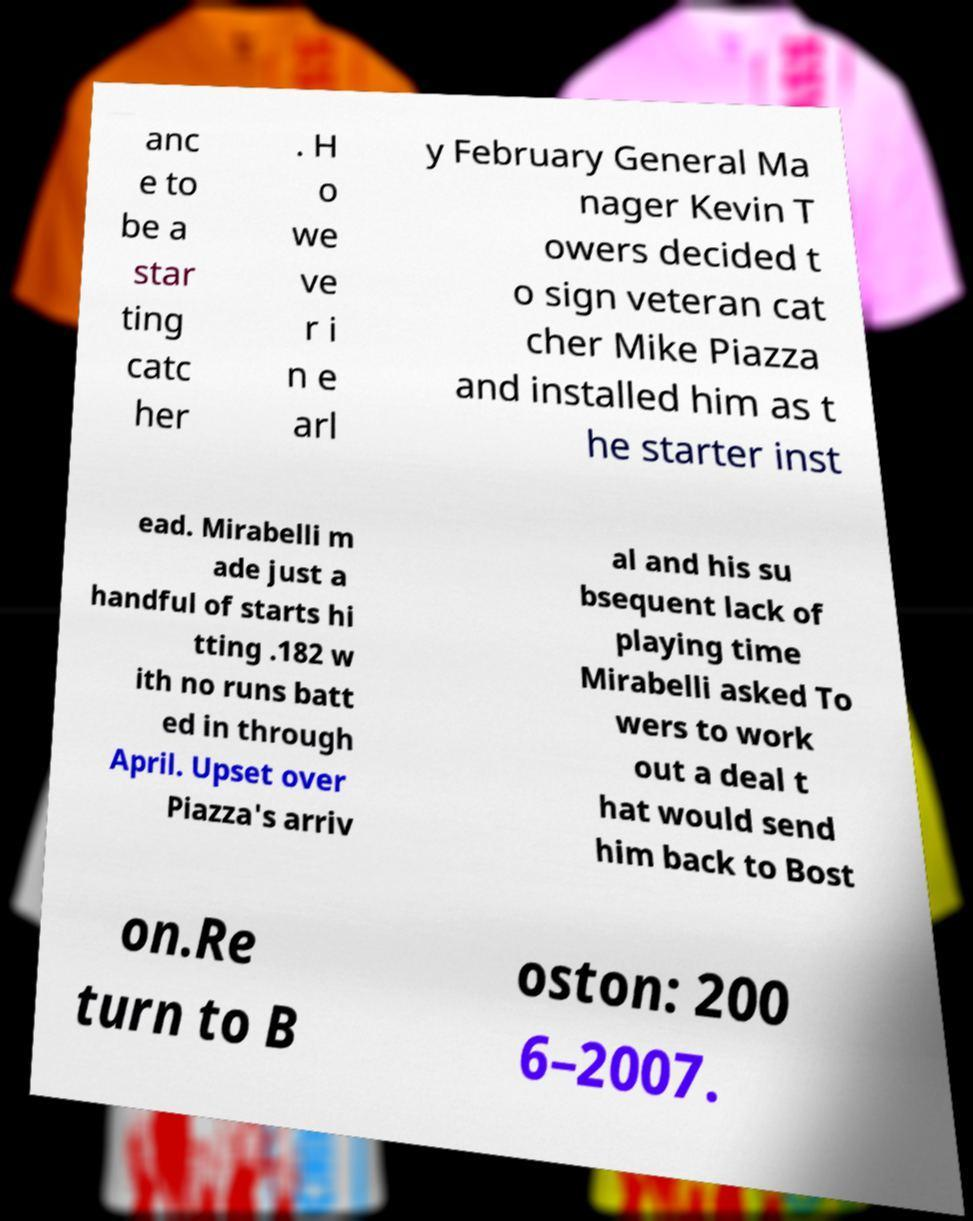Could you extract and type out the text from this image? anc e to be a star ting catc her . H o we ve r i n e arl y February General Ma nager Kevin T owers decided t o sign veteran cat cher Mike Piazza and installed him as t he starter inst ead. Mirabelli m ade just a handful of starts hi tting .182 w ith no runs batt ed in through April. Upset over Piazza's arriv al and his su bsequent lack of playing time Mirabelli asked To wers to work out a deal t hat would send him back to Bost on.Re turn to B oston: 200 6–2007. 